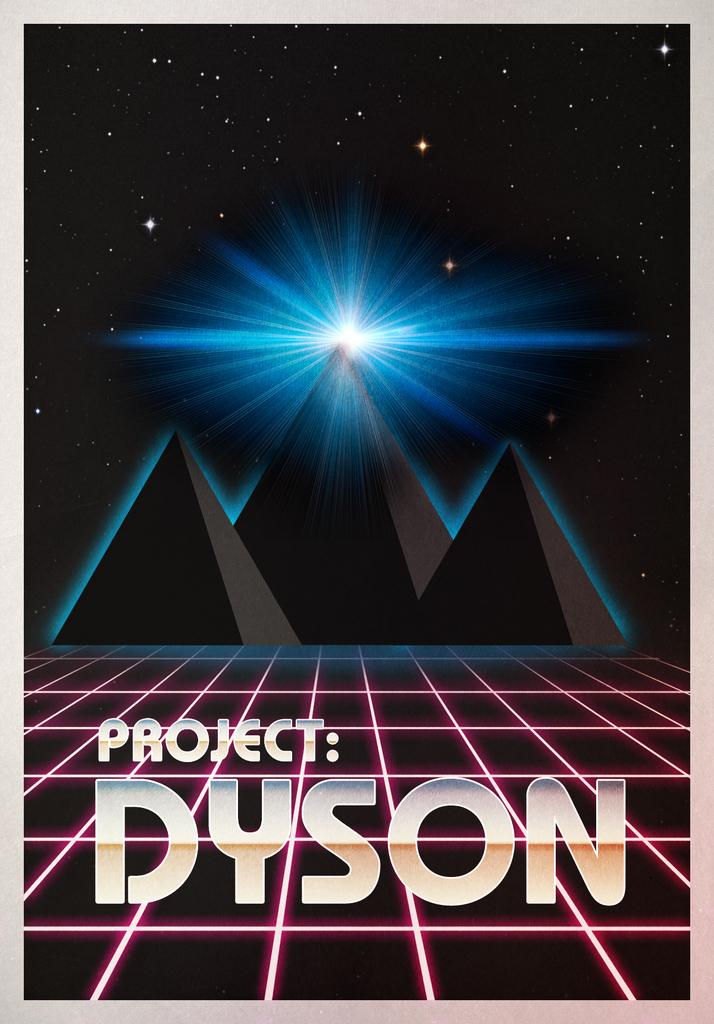<image>
Describe the image concisely. A poster with three pyramids in the background, and the words Project:  Dyson in the foreground. 